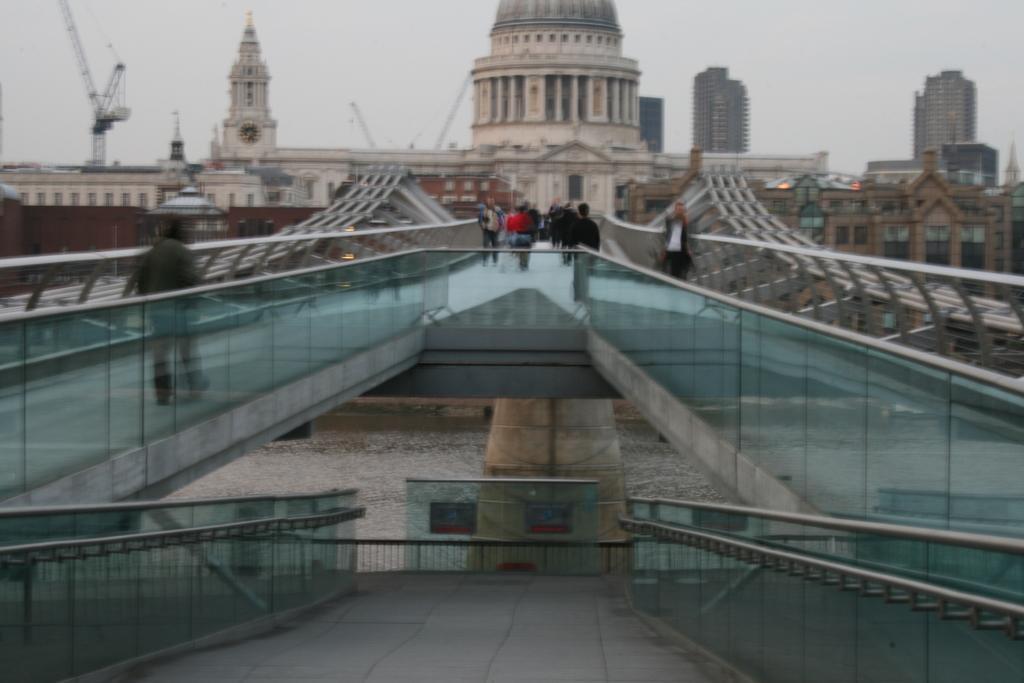How would you summarize this image in a sentence or two? This image consists of a bridge to which there is a railing made up of glass. At the bottom, there is water. In the background, there is a fort and skyscrapers. To the top, there is sky. There are many people walking on the bridge. 